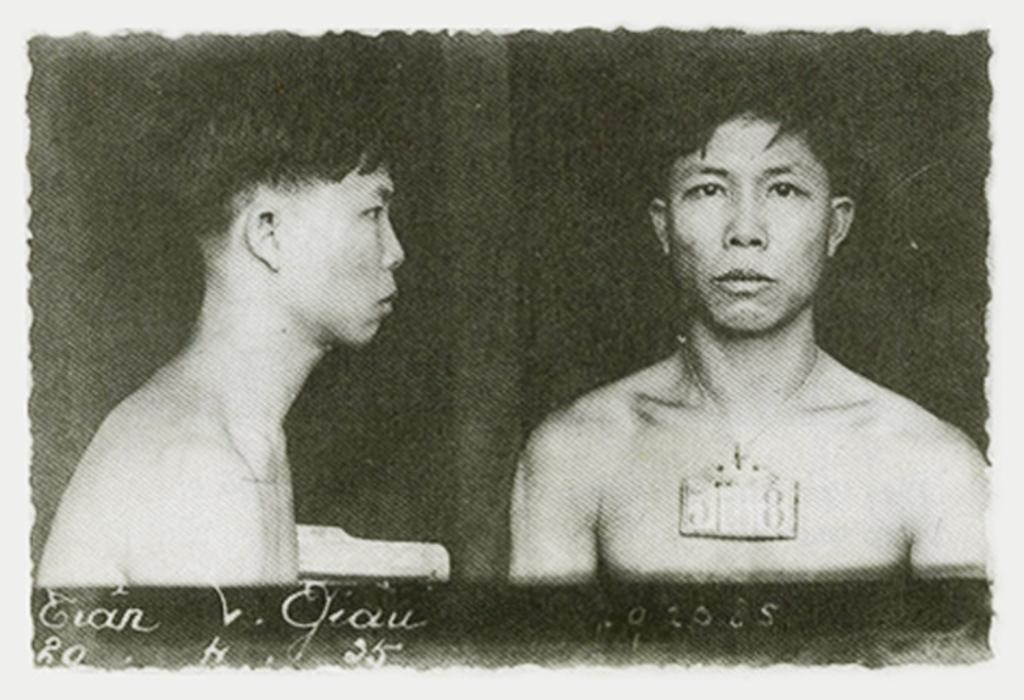What is the color scheme of the poster in the image? The poster is black and white. How many people are depicted on the poster? There are two persons on the poster. Is there any text on the poster? Yes, there is text at the bottom of the poster. What type of steel structure can be seen in the background of the poster? There is no steel structure visible in the image, as the poster is black and white and only features two persons and text at the bottom. Can you tell me how many animals are present in the zoo depicted on the poster? There is no zoo depicted on the poster; it only features two persons and text at the bottom. 